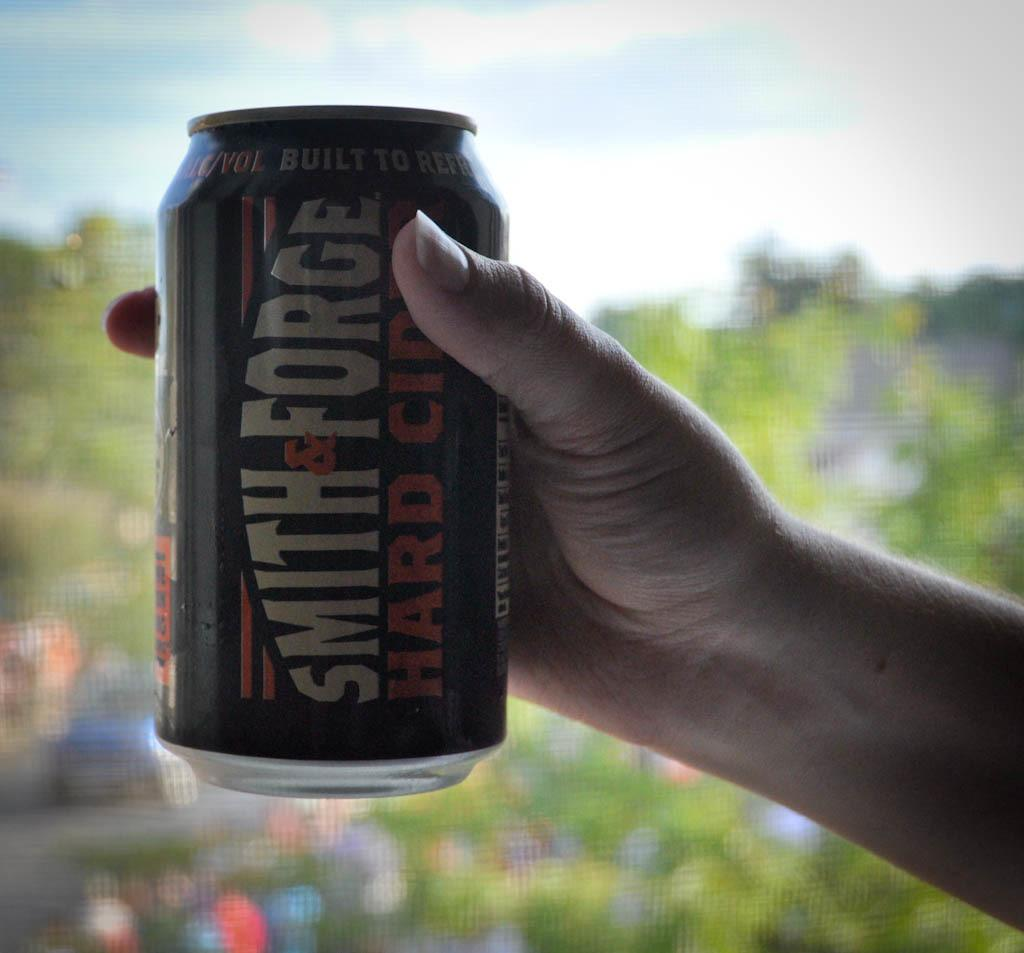<image>
Provide a brief description of the given image. a can that has the name Smith on it 